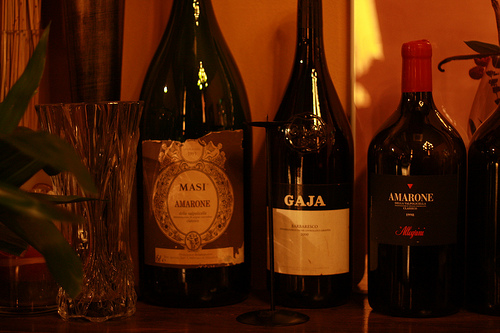<image>
Is the leaf on the glass? Yes. Looking at the image, I can see the leaf is positioned on top of the glass, with the glass providing support. 